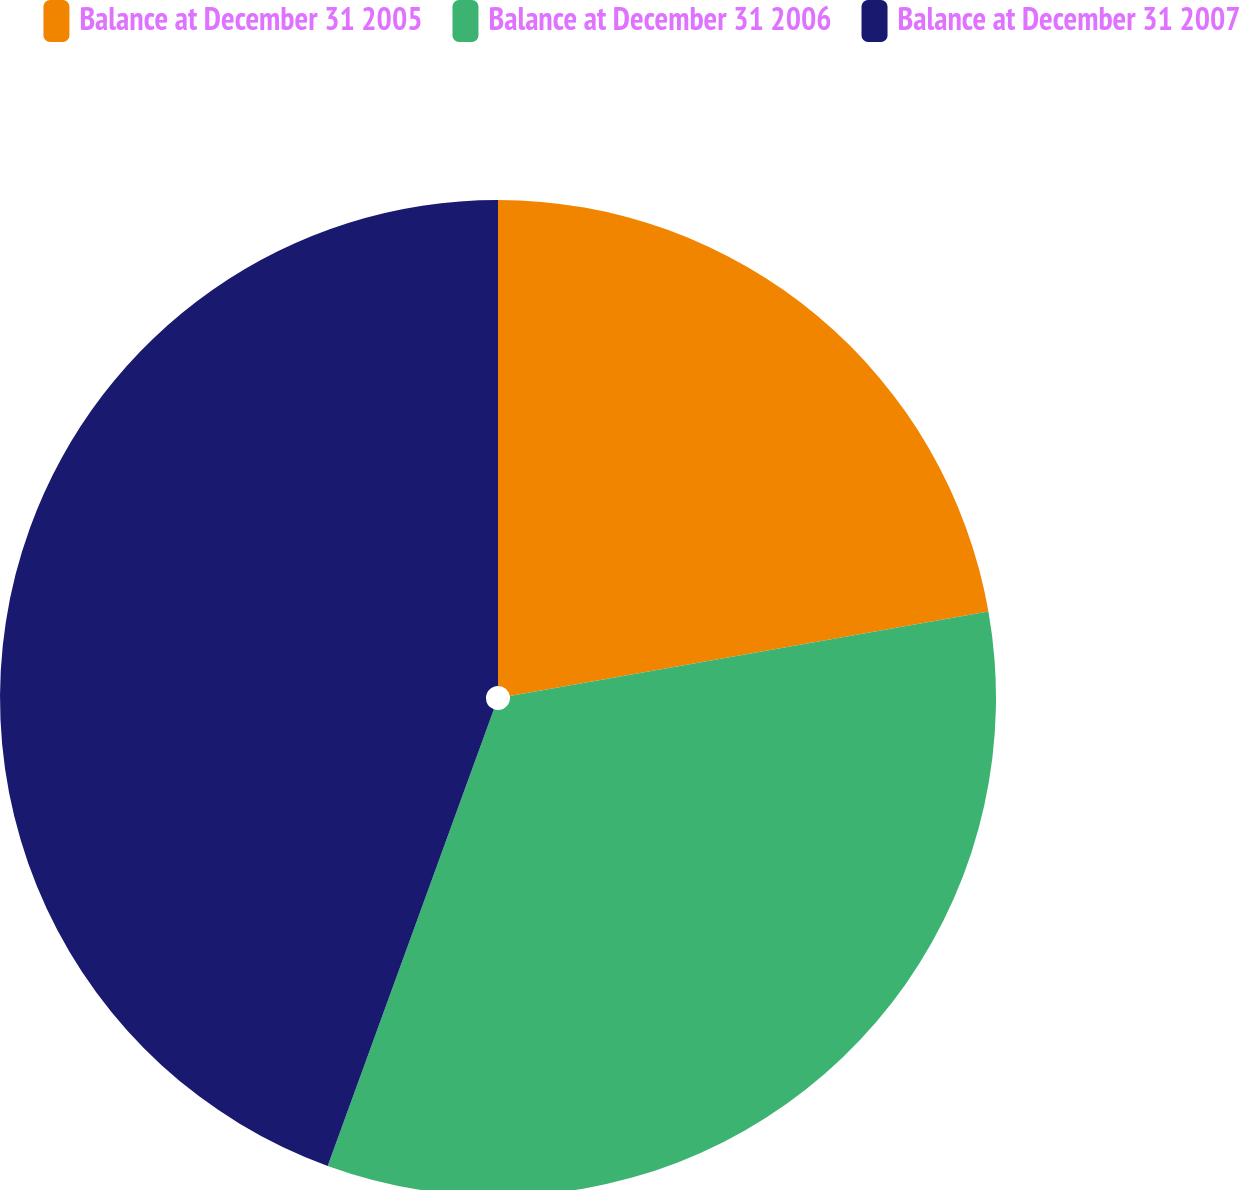Convert chart to OTSL. <chart><loc_0><loc_0><loc_500><loc_500><pie_chart><fcel>Balance at December 31 2005<fcel>Balance at December 31 2006<fcel>Balance at December 31 2007<nl><fcel>22.22%<fcel>33.33%<fcel>44.44%<nl></chart> 